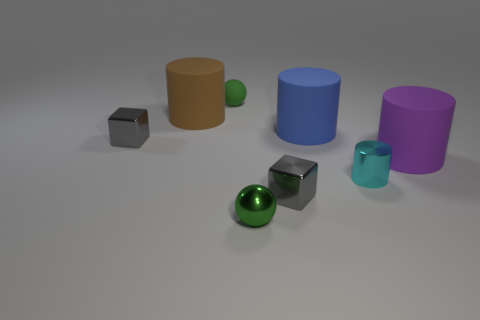There is a blue object; how many large objects are right of it?
Provide a succinct answer. 1. Is the color of the cylinder that is in front of the large purple rubber cylinder the same as the tiny cube that is in front of the small cyan metal thing?
Your answer should be compact. No. What color is the small thing that is the same shape as the large blue object?
Give a very brief answer. Cyan. Is there any other thing that has the same shape as the big brown rubber thing?
Provide a short and direct response. Yes. Do the matte thing right of the metal cylinder and the large matte thing that is left of the tiny green rubber thing have the same shape?
Ensure brevity in your answer.  Yes. Does the brown rubber cylinder have the same size as the green ball on the left side of the small green metal thing?
Your answer should be compact. No. Is the number of small shiny cylinders greater than the number of large gray matte balls?
Your answer should be compact. Yes. Are the small ball in front of the cyan object and the small gray block on the right side of the large brown cylinder made of the same material?
Your answer should be compact. Yes. What is the big brown cylinder made of?
Make the answer very short. Rubber. Are there more things on the right side of the big brown cylinder than rubber things?
Provide a succinct answer. Yes. 